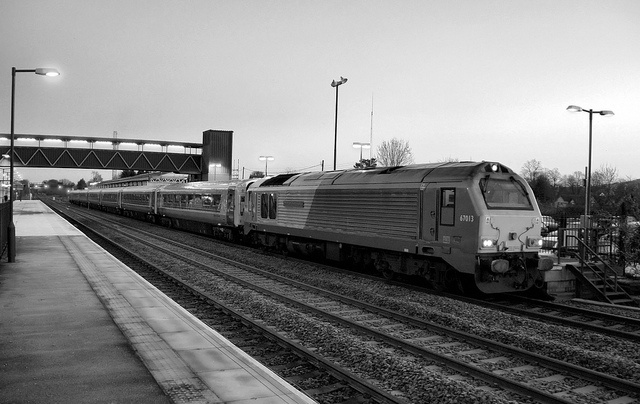Describe the objects in this image and their specific colors. I can see a train in darkgray, black, gray, and lightgray tones in this image. 